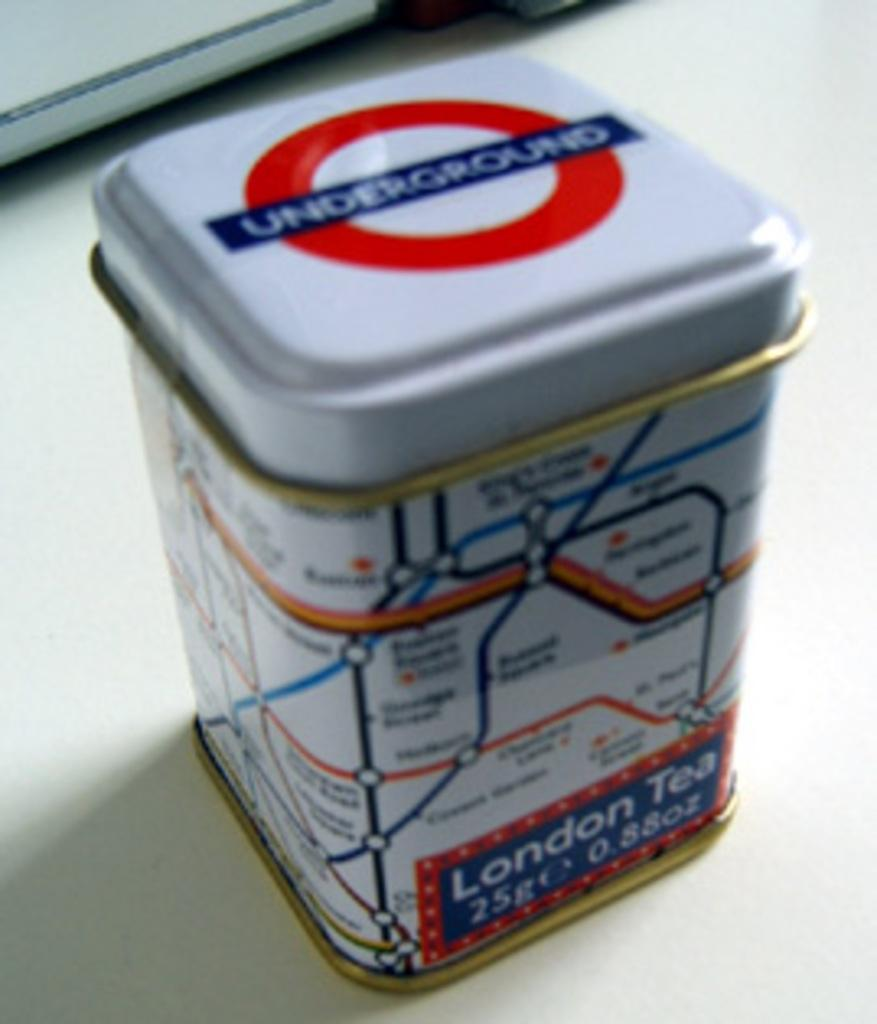<image>
Share a concise interpretation of the image provided. A can of London Tea has the subway map on it. 